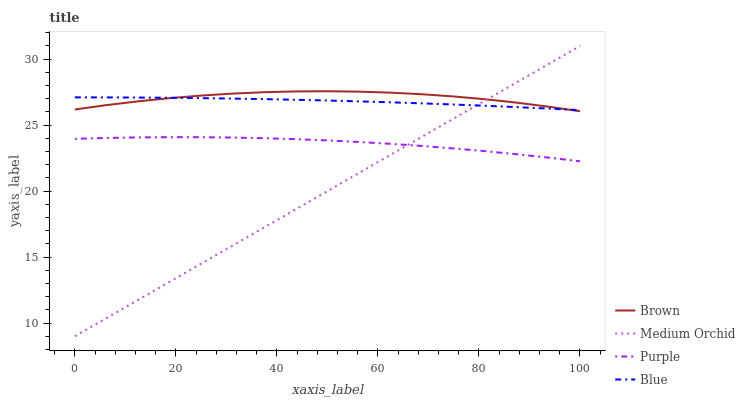Does Medium Orchid have the minimum area under the curve?
Answer yes or no. Yes. Does Brown have the maximum area under the curve?
Answer yes or no. Yes. Does Brown have the minimum area under the curve?
Answer yes or no. No. Does Medium Orchid have the maximum area under the curve?
Answer yes or no. No. Is Medium Orchid the smoothest?
Answer yes or no. Yes. Is Brown the roughest?
Answer yes or no. Yes. Is Brown the smoothest?
Answer yes or no. No. Is Medium Orchid the roughest?
Answer yes or no. No. Does Medium Orchid have the lowest value?
Answer yes or no. Yes. Does Brown have the lowest value?
Answer yes or no. No. Does Medium Orchid have the highest value?
Answer yes or no. Yes. Does Brown have the highest value?
Answer yes or no. No. Is Purple less than Brown?
Answer yes or no. Yes. Is Blue greater than Purple?
Answer yes or no. Yes. Does Blue intersect Medium Orchid?
Answer yes or no. Yes. Is Blue less than Medium Orchid?
Answer yes or no. No. Is Blue greater than Medium Orchid?
Answer yes or no. No. Does Purple intersect Brown?
Answer yes or no. No. 